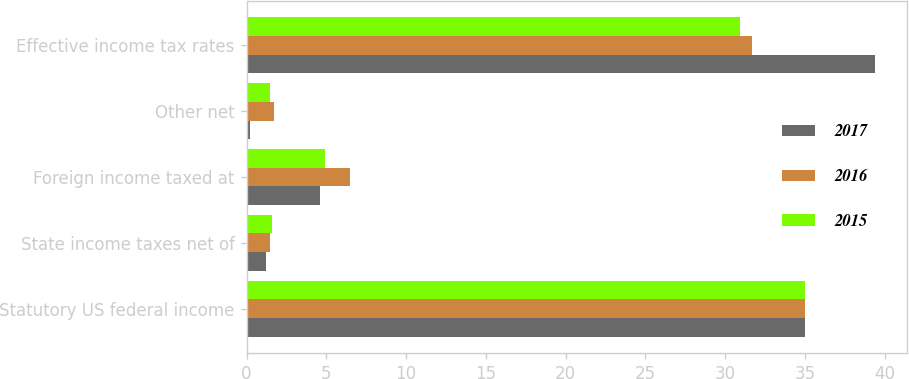<chart> <loc_0><loc_0><loc_500><loc_500><stacked_bar_chart><ecel><fcel>Statutory US federal income<fcel>State income taxes net of<fcel>Foreign income taxed at<fcel>Other net<fcel>Effective income tax rates<nl><fcel>2017<fcel>35<fcel>1.2<fcel>4.6<fcel>0.2<fcel>39.4<nl><fcel>2016<fcel>35<fcel>1.5<fcel>6.5<fcel>1.7<fcel>31.7<nl><fcel>2015<fcel>35<fcel>1.6<fcel>4.9<fcel>1.5<fcel>30.9<nl></chart> 